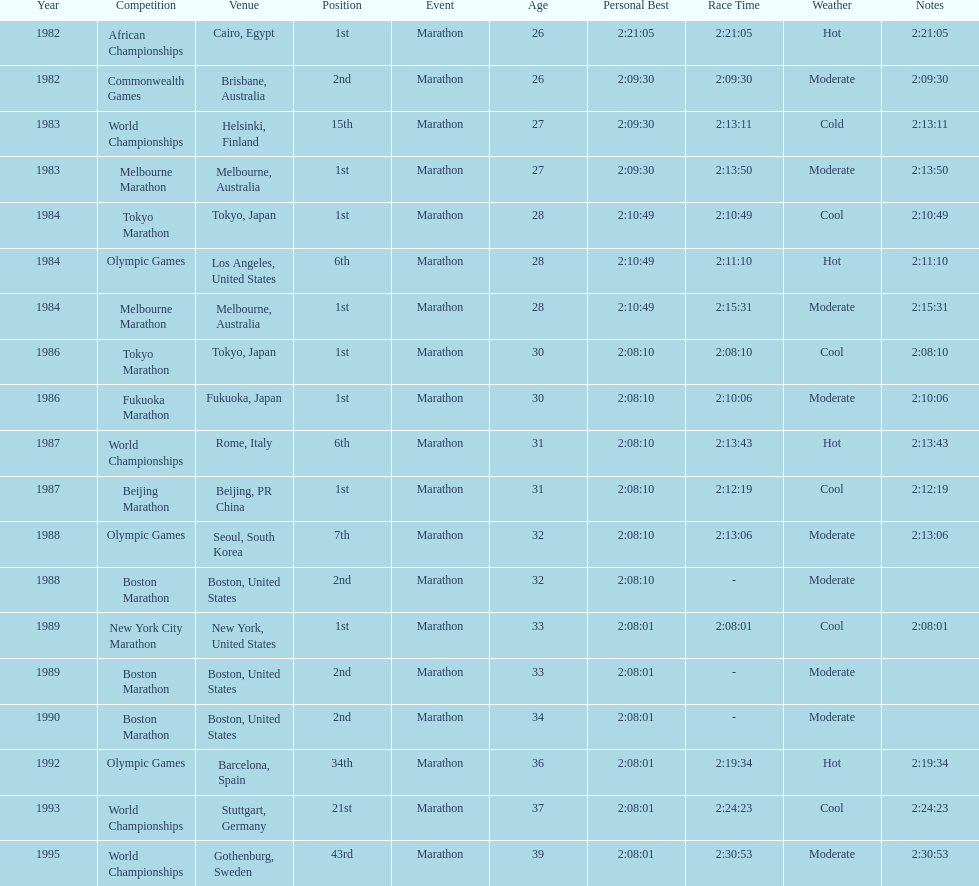Could you parse the entire table? {'header': ['Year', 'Competition', 'Venue', 'Position', 'Event', 'Age', 'Personal Best', 'Race Time', 'Weather', 'Notes'], 'rows': [['1982', 'African Championships', 'Cairo, Egypt', '1st', 'Marathon', '26', '2:21:05', '2:21:05', 'Hot', '2:21:05'], ['1982', 'Commonwealth Games', 'Brisbane, Australia', '2nd', 'Marathon', '26', '2:09:30', '2:09:30', 'Moderate', '2:09:30'], ['1983', 'World Championships', 'Helsinki, Finland', '15th', 'Marathon', '27', '2:09:30', '2:13:11', 'Cold', '2:13:11'], ['1983', 'Melbourne Marathon', 'Melbourne, Australia', '1st', 'Marathon', '27', '2:09:30', '2:13:50', 'Moderate', '2:13:50'], ['1984', 'Tokyo Marathon', 'Tokyo, Japan', '1st', 'Marathon', '28', '2:10:49', '2:10:49', 'Cool', '2:10:49'], ['1984', 'Olympic Games', 'Los Angeles, United States', '6th', 'Marathon', '28', '2:10:49', '2:11:10', 'Hot', '2:11:10'], ['1984', 'Melbourne Marathon', 'Melbourne, Australia', '1st', 'Marathon', '28', '2:10:49', '2:15:31', 'Moderate', '2:15:31'], ['1986', 'Tokyo Marathon', 'Tokyo, Japan', '1st', 'Marathon', '30', '2:08:10', '2:08:10', 'Cool', '2:08:10'], ['1986', 'Fukuoka Marathon', 'Fukuoka, Japan', '1st', 'Marathon', '30', '2:08:10', '2:10:06', 'Moderate', '2:10:06'], ['1987', 'World Championships', 'Rome, Italy', '6th', 'Marathon', '31', '2:08:10', '2:13:43', 'Hot', '2:13:43'], ['1987', 'Beijing Marathon', 'Beijing, PR China', '1st', 'Marathon', '31', '2:08:10', '2:12:19', 'Cool', '2:12:19'], ['1988', 'Olympic Games', 'Seoul, South Korea', '7th', 'Marathon', '32', '2:08:10', '2:13:06', 'Moderate', '2:13:06'], ['1988', 'Boston Marathon', 'Boston, United States', '2nd', 'Marathon', '32', '2:08:10', '-', 'Moderate', ''], ['1989', 'New York City Marathon', 'New York, United States', '1st', 'Marathon', '33', '2:08:01', '2:08:01', 'Cool', '2:08:01'], ['1989', 'Boston Marathon', 'Boston, United States', '2nd', 'Marathon', '33', '2:08:01', '-', 'Moderate', ''], ['1990', 'Boston Marathon', 'Boston, United States', '2nd', 'Marathon', '34', '2:08:01', '-', 'Moderate', ''], ['1992', 'Olympic Games', 'Barcelona, Spain', '34th', 'Marathon', '36', '2:08:01', '2:19:34', 'Hot', '2:19:34'], ['1993', 'World Championships', 'Stuttgart, Germany', '21st', 'Marathon', '37', '2:08:01', '2:24:23', 'Cool', '2:24:23'], ['1995', 'World Championships', 'Gothenburg, Sweden', '43rd', 'Marathon', '39', '2:08:01', '2:30:53', 'Moderate', '2:30:53']]} What are the total number of times the position of 1st place was earned? 8. 